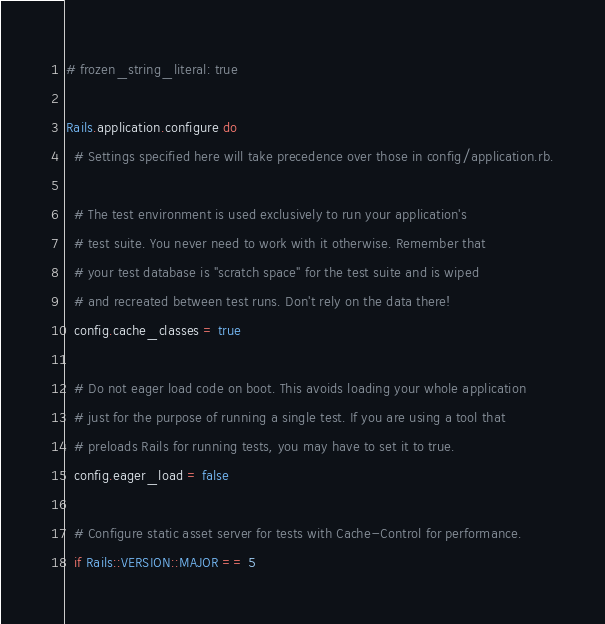<code> <loc_0><loc_0><loc_500><loc_500><_Ruby_># frozen_string_literal: true

Rails.application.configure do
  # Settings specified here will take precedence over those in config/application.rb.

  # The test environment is used exclusively to run your application's
  # test suite. You never need to work with it otherwise. Remember that
  # your test database is "scratch space" for the test suite and is wiped
  # and recreated between test runs. Don't rely on the data there!
  config.cache_classes = true

  # Do not eager load code on boot. This avoids loading your whole application
  # just for the purpose of running a single test. If you are using a tool that
  # preloads Rails for running tests, you may have to set it to true.
  config.eager_load = false

  # Configure static asset server for tests with Cache-Control for performance.
  if Rails::VERSION::MAJOR == 5</code> 